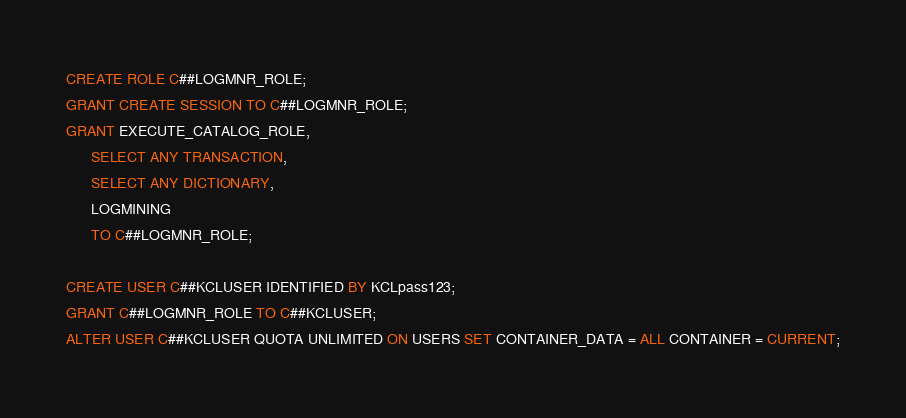<code> <loc_0><loc_0><loc_500><loc_500><_SQL_>CREATE ROLE C##LOGMNR_ROLE;
GRANT CREATE SESSION TO C##LOGMNR_ROLE;
GRANT EXECUTE_CATALOG_ROLE, 
      SELECT ANY TRANSACTION,
      SELECT ANY DICTIONARY,
      LOGMINING
      TO C##LOGMNR_ROLE;

CREATE USER C##KCLUSER IDENTIFIED BY KCLpass123;
GRANT C##LOGMNR_ROLE TO C##KCLUSER;
ALTER USER C##KCLUSER QUOTA UNLIMITED ON USERS SET CONTAINER_DATA = ALL CONTAINER = CURRENT;
</code> 